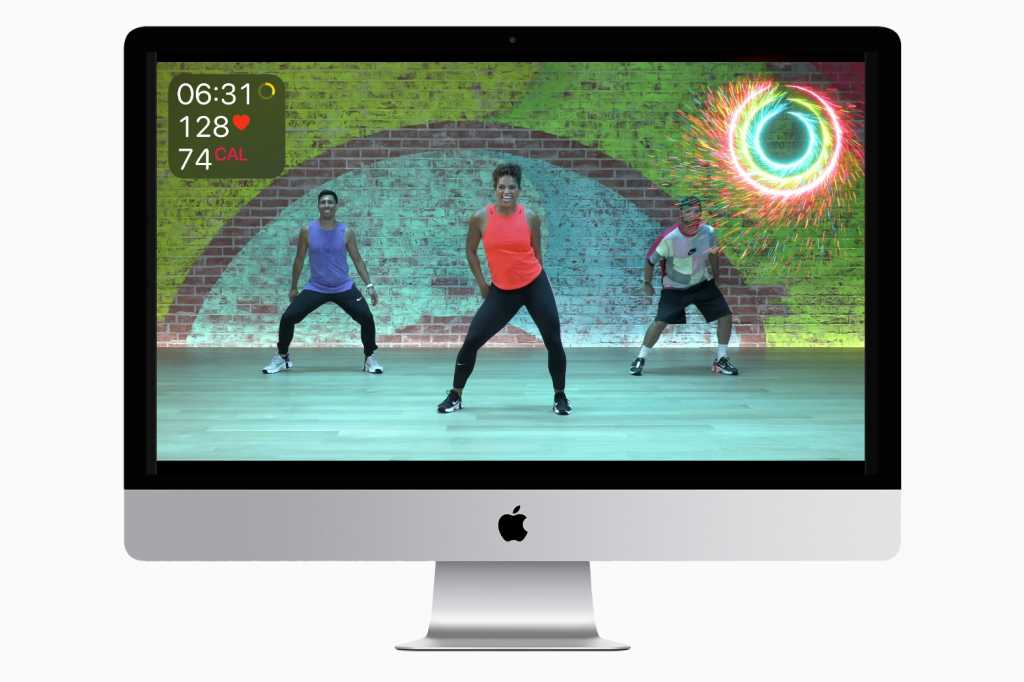Why are the participants wearing different colored workout clothes? The participants might be wearing different colored workout clothes to help distinguish between individual users or to make the visual experience more dynamic and engaging. It can also serve to highlight different roles within the workout session, such as instructors and trainees, or to simply inject a sense of personal style and preference into the workout environment. Can the application provide different types of workouts? Yes, it is highly likely that the application offers a variety of workout types to cater to diverse user preferences and fitness goals. This could include options for cardio, strength training, flexibility exercises, or interval training. By providing multiple workout types, the application can accommodate users of different fitness levels and interests, promoting a well-rounded fitness regimen. Imagine the software could talk. What motivational phrase might it use to encourage users during a tough workout session? “You’re doing amazing! Every drop of sweat is a step closer to your goal. Keep pushing, you've got this!” What kind of data privacy concerns might users have with this fitness software? Users might have concerns regarding the privacy and security of their personal health data, such as heart rate and calorie expenditures, which are being tracked by the software. Additionally, there can be worries about how this data is stored, processed, and potentially shared with third parties. Ensuring robust data encryption, transparent privacy policies, and giving users control over their data are essential measures that can address these concerns. 